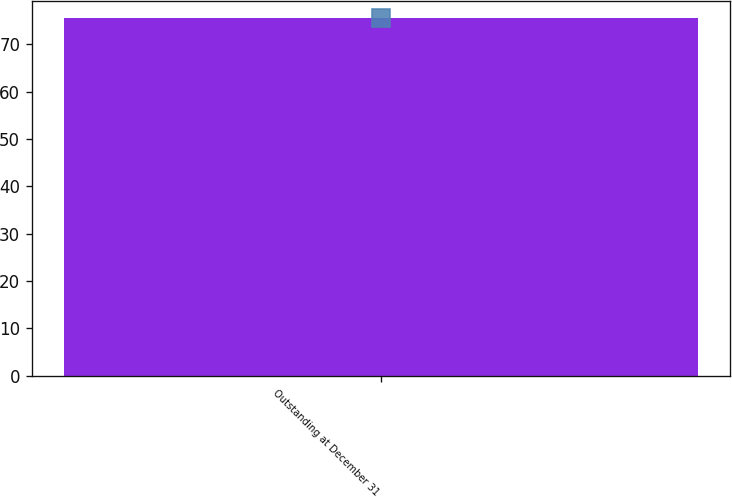Convert chart to OTSL. <chart><loc_0><loc_0><loc_500><loc_500><bar_chart><fcel>Outstanding at December 31<nl><fcel>75.43<nl></chart> 